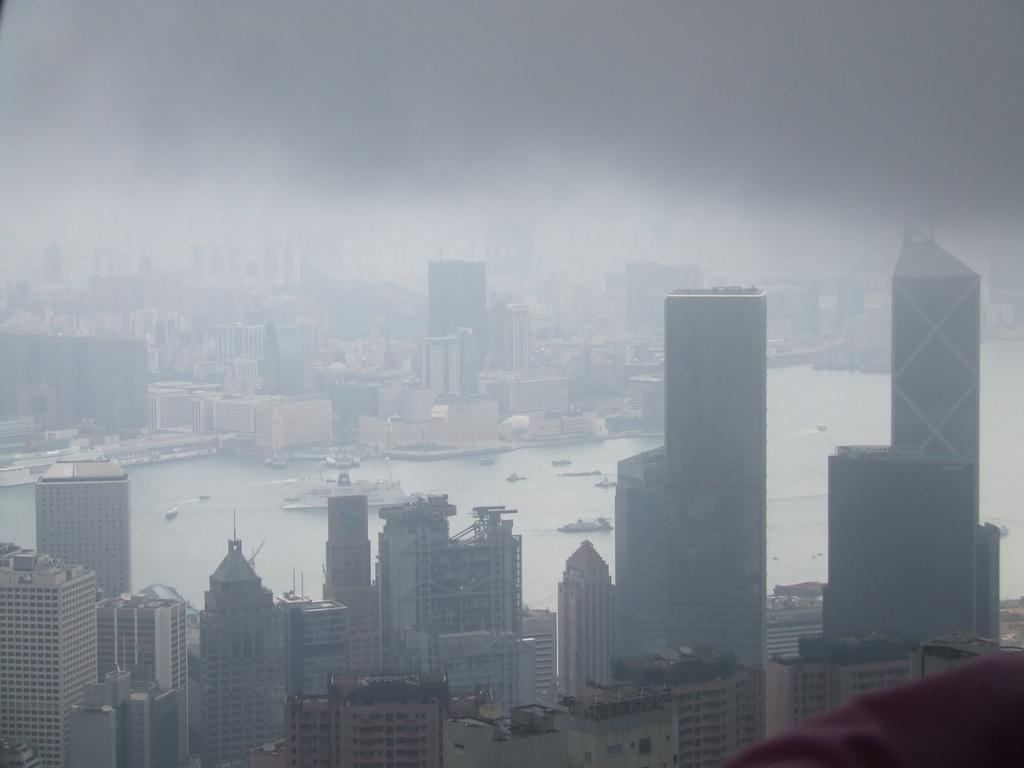Describe this image in one or two sentences. In this image, I can see the skyscrapers and buildings. I can see a ship and the boats on the water. 